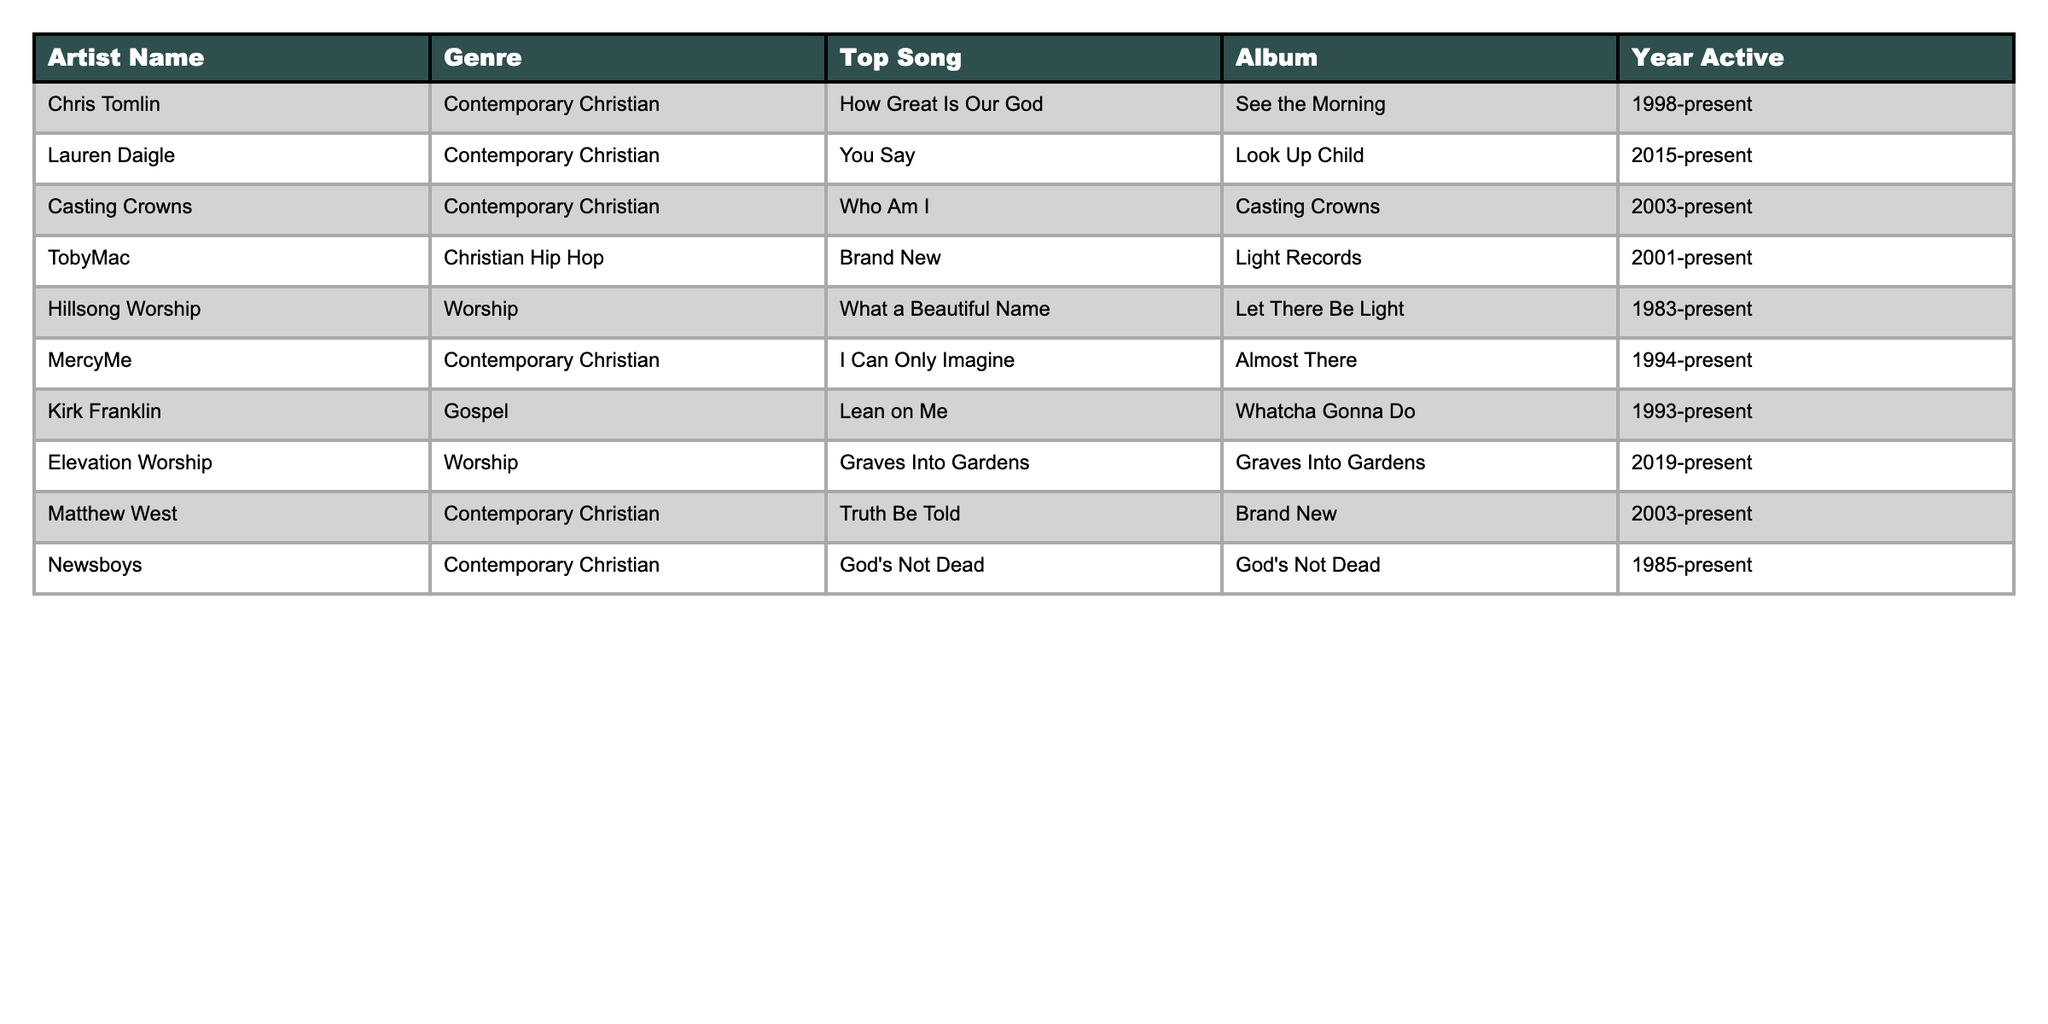What is the top song of Chris Tomlin? The table shows that Chris Tomlin's top song is listed as "How Great Is Our God."
Answer: How Great Is Our God Which artist has the longest active career? By comparing the year active column, Hillsong Worship started in 1983, making it the longest active artist.
Answer: Hillsong Worship Is there an artist whose top song is also the title of their album? The table indicates that Casting Crowns’ top song is "Who Am I," which matches the title of their album.
Answer: Yes How many artists are in the Contemporary Christian genre? Counting the artists listed under Contemporary Christian in the genre column, there are five: Chris Tomlin, Lauren Daigle, Casting Crowns, MercyMe, and Matthew West.
Answer: 5 Which genre has the least number of artists represented? In the table, the Christian Hip Hop genre has only one artist, TobyMac.
Answer: Christian Hip Hop List all artists who have released music since 2015. Checking the year active, Lauren Daigle (2015-present) and Elevation Worship (2019-present) are the artists active since 2015.
Answer: Lauren Daigle, Elevation Worship Which artist's top song was released in the same year they became active? The top song for Elevation Worship, "Graves Into Gardens," was released in 2019, which is the same year they became active.
Answer: Elevation Worship What is the total number of artists active from 1990 onwards? Counting the artists starting from 1990, there are six: MercyMe (1994), Kirk Franklin (1993), TobyMac (2001), Casting Crowns (2003), Matthew West (2003), and Lauren Daigle (2015).
Answer: 6 Does any artist in the Gospel genre have a top song that was released in a different year than their active start? Kirk Franklin has been active since 1993 with the top song "Lean on Me," which is from his album "Whatcha Gonna Do," released also before his active start.
Answer: No What percentage of the artists are categorized under Worship? The total number of artists is 10, and there are 3 artists under Worship (Hillsong Worship, Elevation Worship). The calculation is (3/10)*100 = 30%.
Answer: 30% 